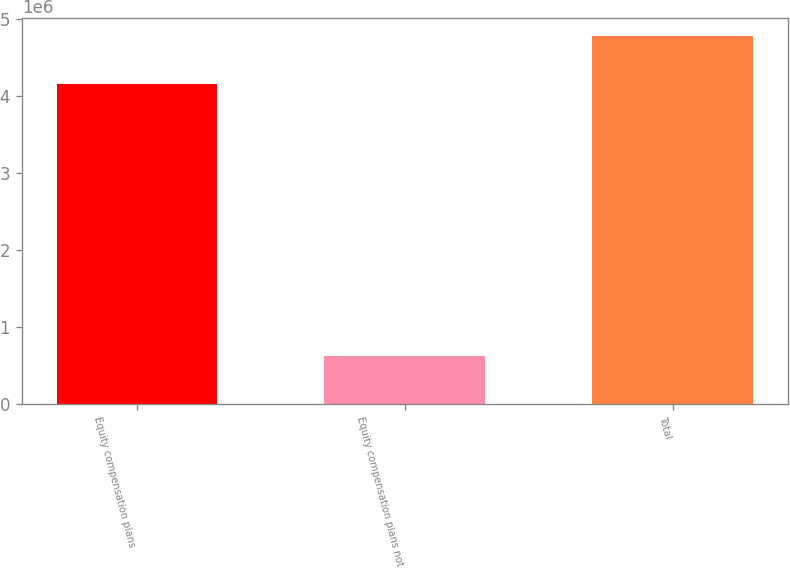Convert chart to OTSL. <chart><loc_0><loc_0><loc_500><loc_500><bar_chart><fcel>Equity compensation plans<fcel>Equity compensation plans not<fcel>Total<nl><fcel>4.15507e+06<fcel>620144<fcel>4.77522e+06<nl></chart> 